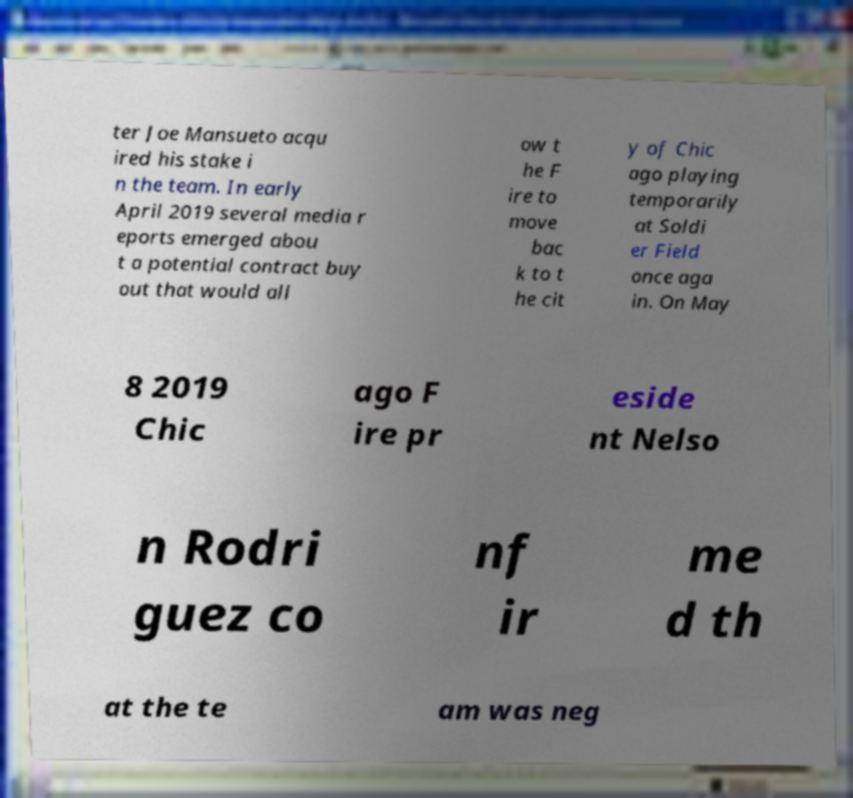What messages or text are displayed in this image? I need them in a readable, typed format. ter Joe Mansueto acqu ired his stake i n the team. In early April 2019 several media r eports emerged abou t a potential contract buy out that would all ow t he F ire to move bac k to t he cit y of Chic ago playing temporarily at Soldi er Field once aga in. On May 8 2019 Chic ago F ire pr eside nt Nelso n Rodri guez co nf ir me d th at the te am was neg 